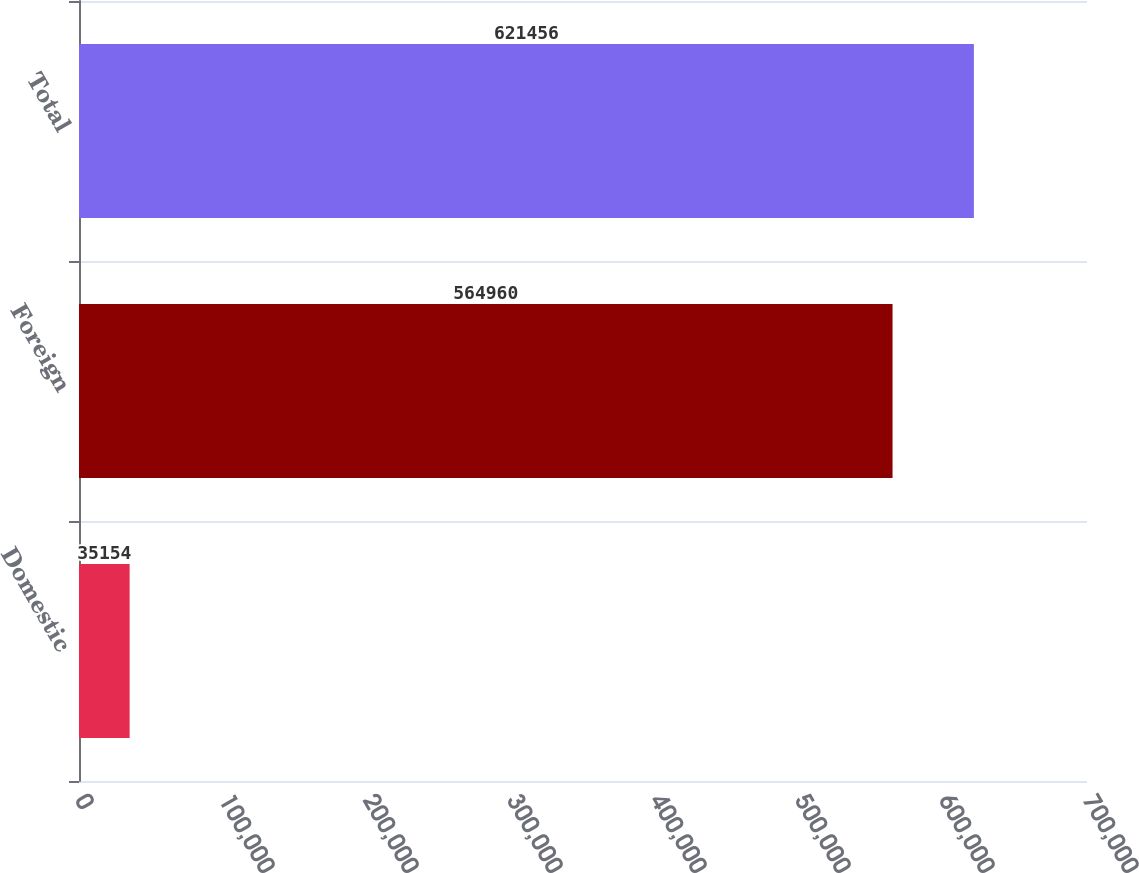<chart> <loc_0><loc_0><loc_500><loc_500><bar_chart><fcel>Domestic<fcel>Foreign<fcel>Total<nl><fcel>35154<fcel>564960<fcel>621456<nl></chart> 